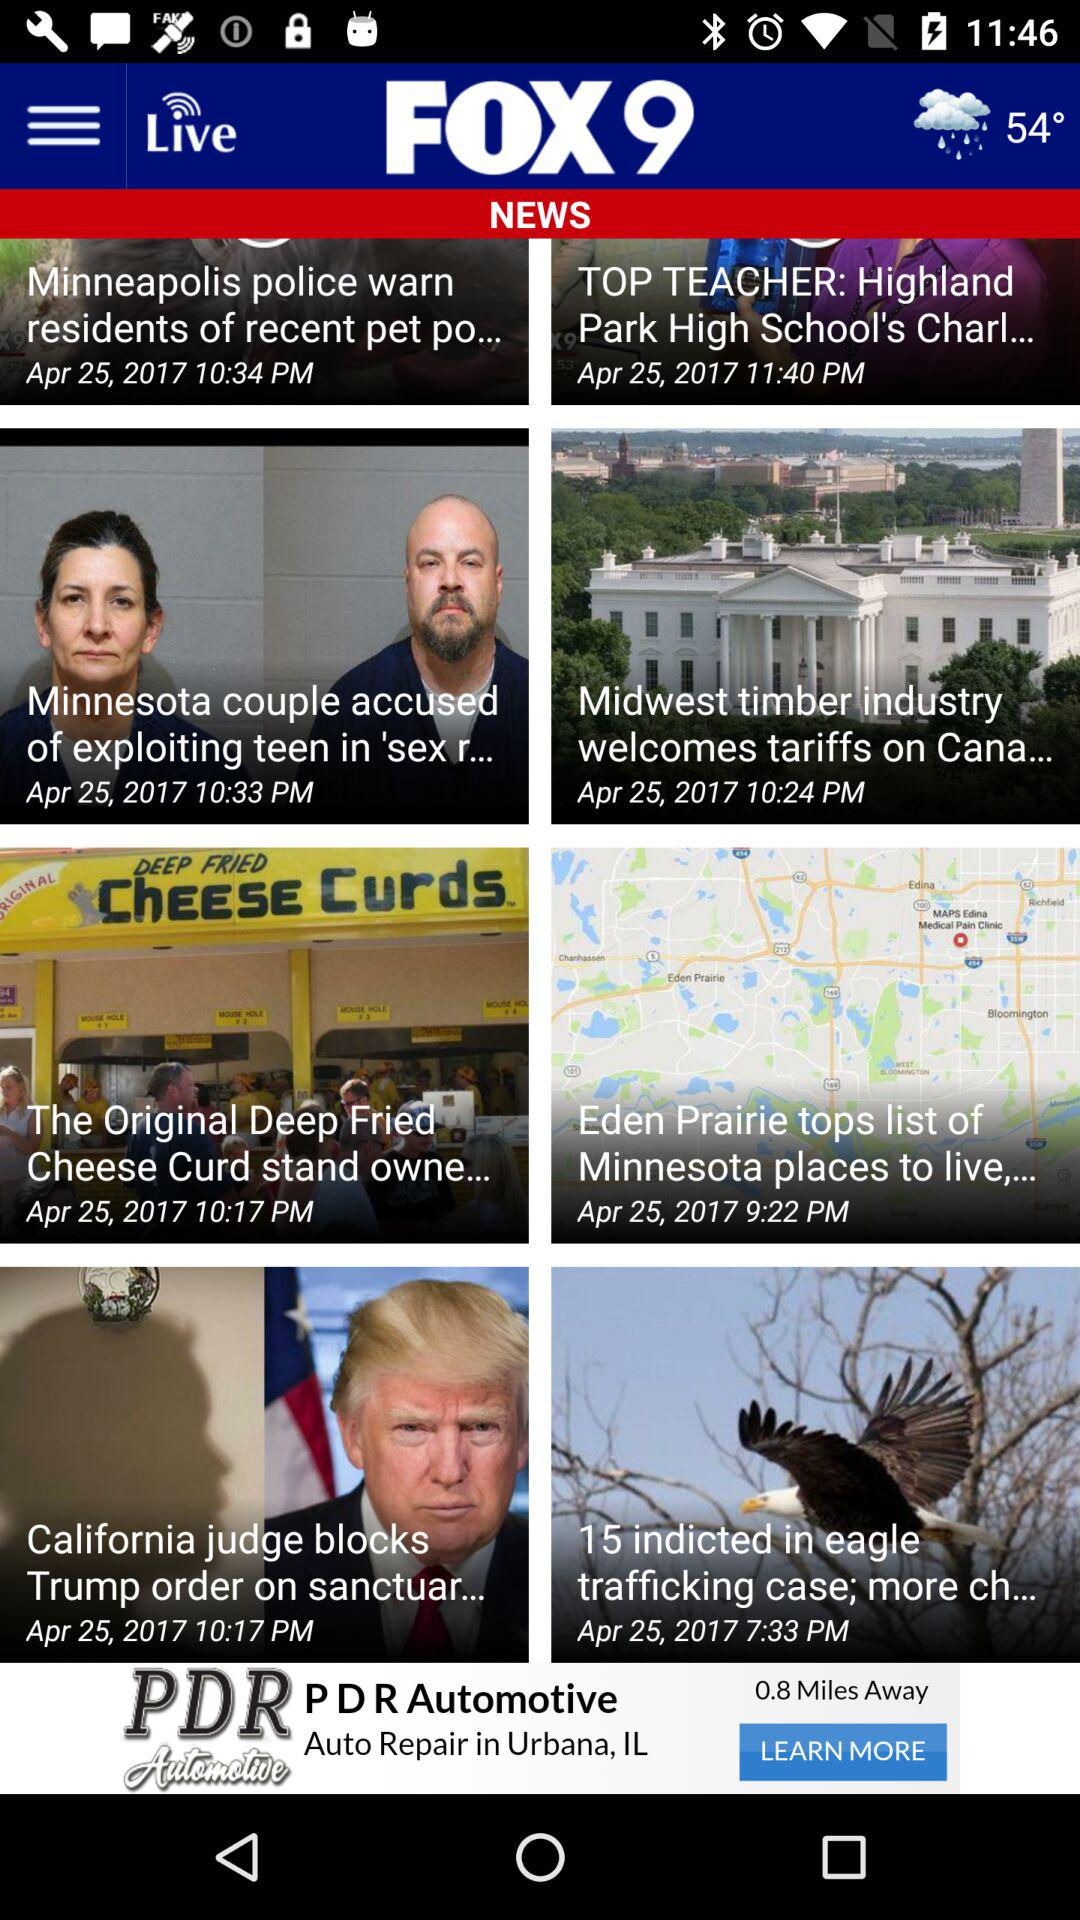What is the application name? The application name is "FOX 9". 